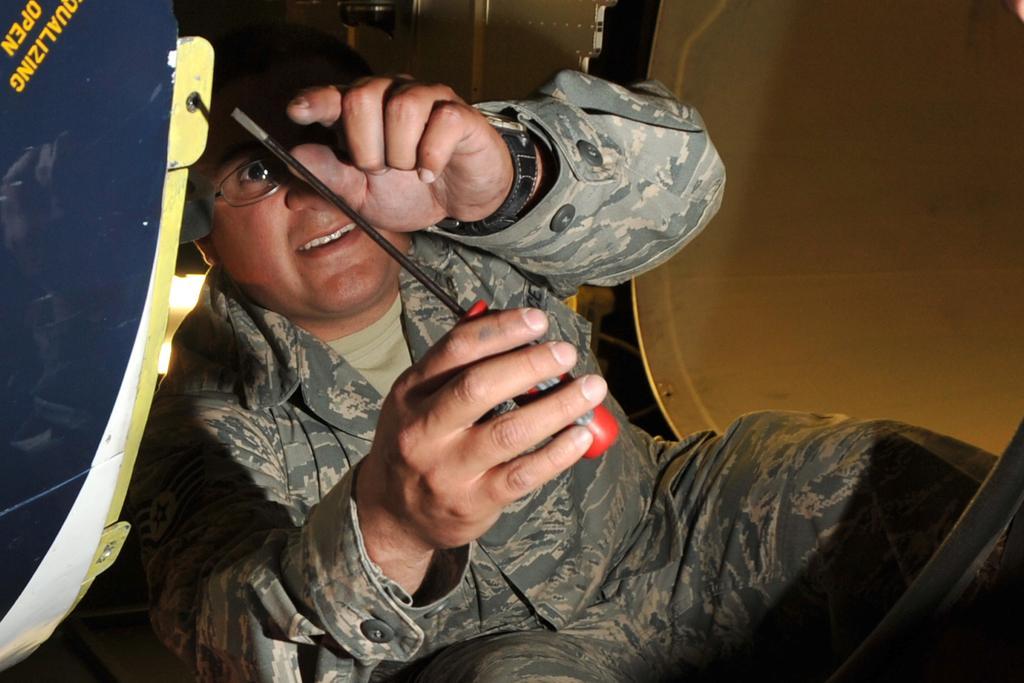Could you give a brief overview of what you see in this image? In this image, we can see a person in a military uniform is holding a screwdriver. Here we can see few objects and some text. 